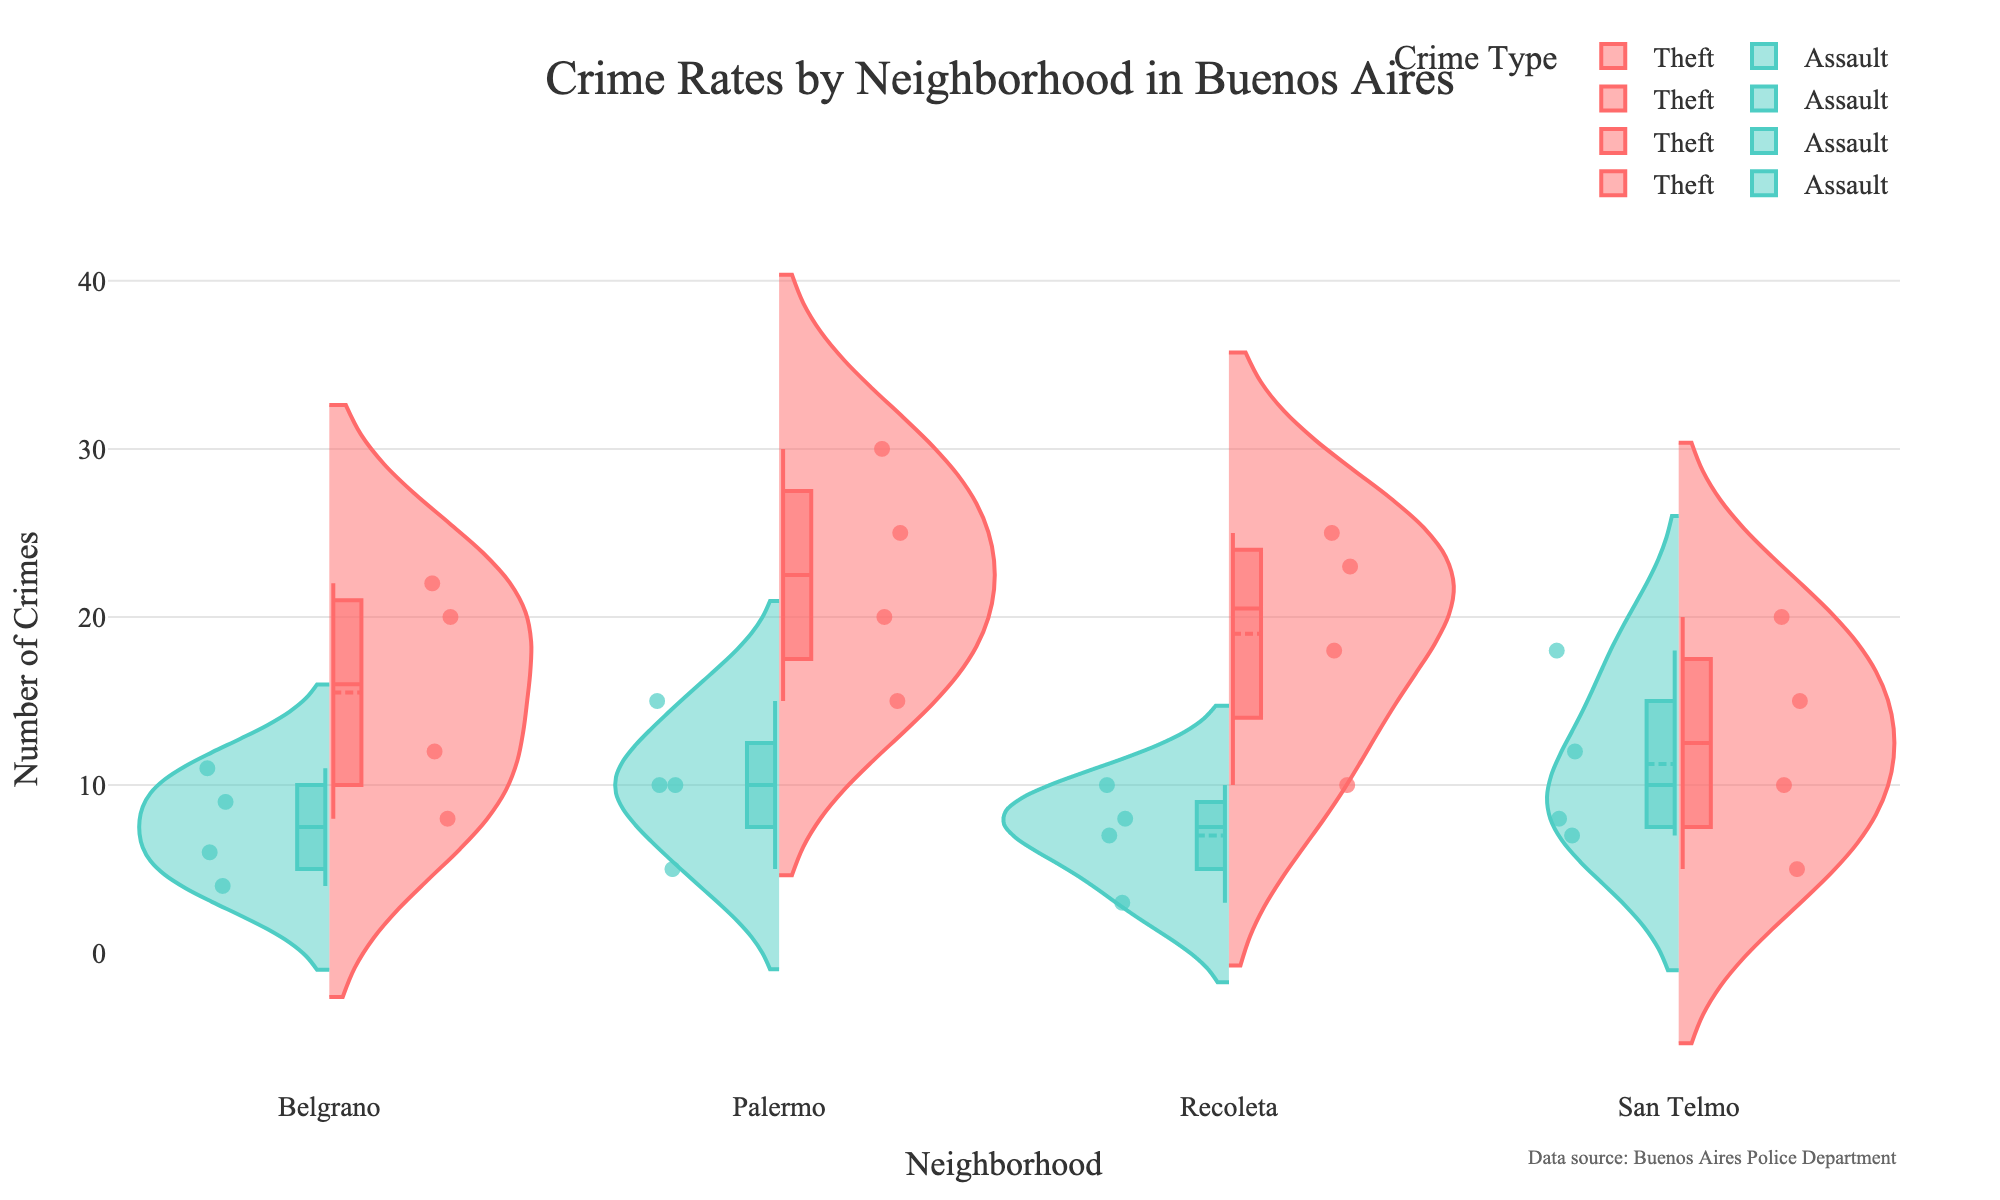Which neighborhood has the highest number of Theft crimes in the Night? Palermo has the highest Theft crimes at Night. Each violin split represents this, and Palermo's Theft side is the highest in the Night segment.
Answer: Palermo Which Crime Type shows more variability in Palermo, Theft or Assault? Palermo's Theft crimes show more variability; the Violins' spread wider compared to Assault, evidencing a greater range of crime counts.
Answer: Theft How many crimes of all types are there in Recoleta during the Morning? Adding Theft (10) and Assault (3) from Recoleta during Morning equals 13 crimes in total.
Answer: 13 In which time slot does Belgrano experience the highest number of total crimes? Belgrano has the highest combined crime counts in the Night, aggregating both Theft and Assault counts visibly higher than other time slots.
Answer: Night Compare the number of Assaults in San Telmo and Recoleta at Night. Which one is higher? San Telmo has 18 Assaults at Night, Recoleta has 10, making San Telmo the higher.
Answer: San Telmo What is the total number of Thefts reported in San Telmo? Summing Thefts across all time slots for San Telmo: 5 (Morning) + 10 (Afternoon) + 15 (Evening) + 20 (Night) equals 50 Thefts.
Answer: 50 Which neighborhood shows the least difference between the number of Theft crimes and Assault crimes at Night? Recoleta shows the least difference in Night crimes: 25 Theft vs. 10 Assault with a difference of 15. Other neighborhoods have larger disparities.
Answer: Recoleta Which crime type in Palermo displays an increasing trend over time from Morning to Night? Both Theft and Assault in Palermo trend upwards from Morning with increasing counts towards Night.
Answer: Both How does the count of Theft crimes in Belgrano during Night compare to the count of Assault crimes in Palermo during Evening? Belgrano Night Thefts (22) are slightly higher than Palermo Evening Assaults (10).
Answer: Higher 